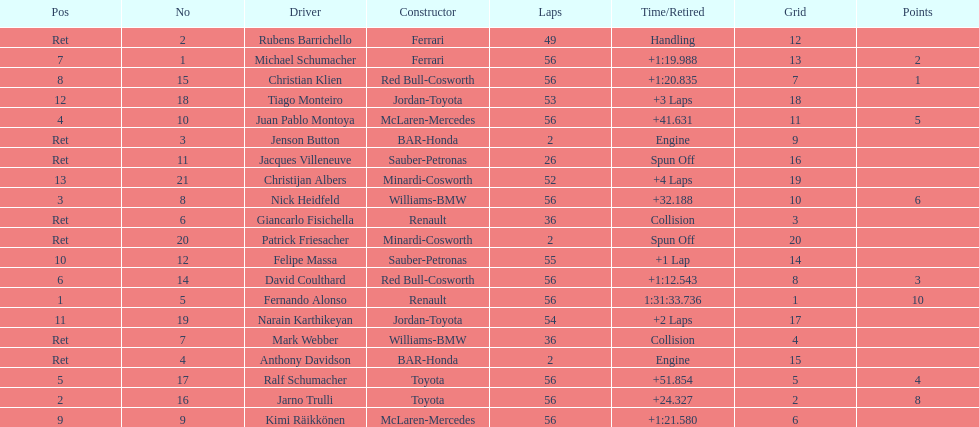How many bmws finished before webber? 1. 